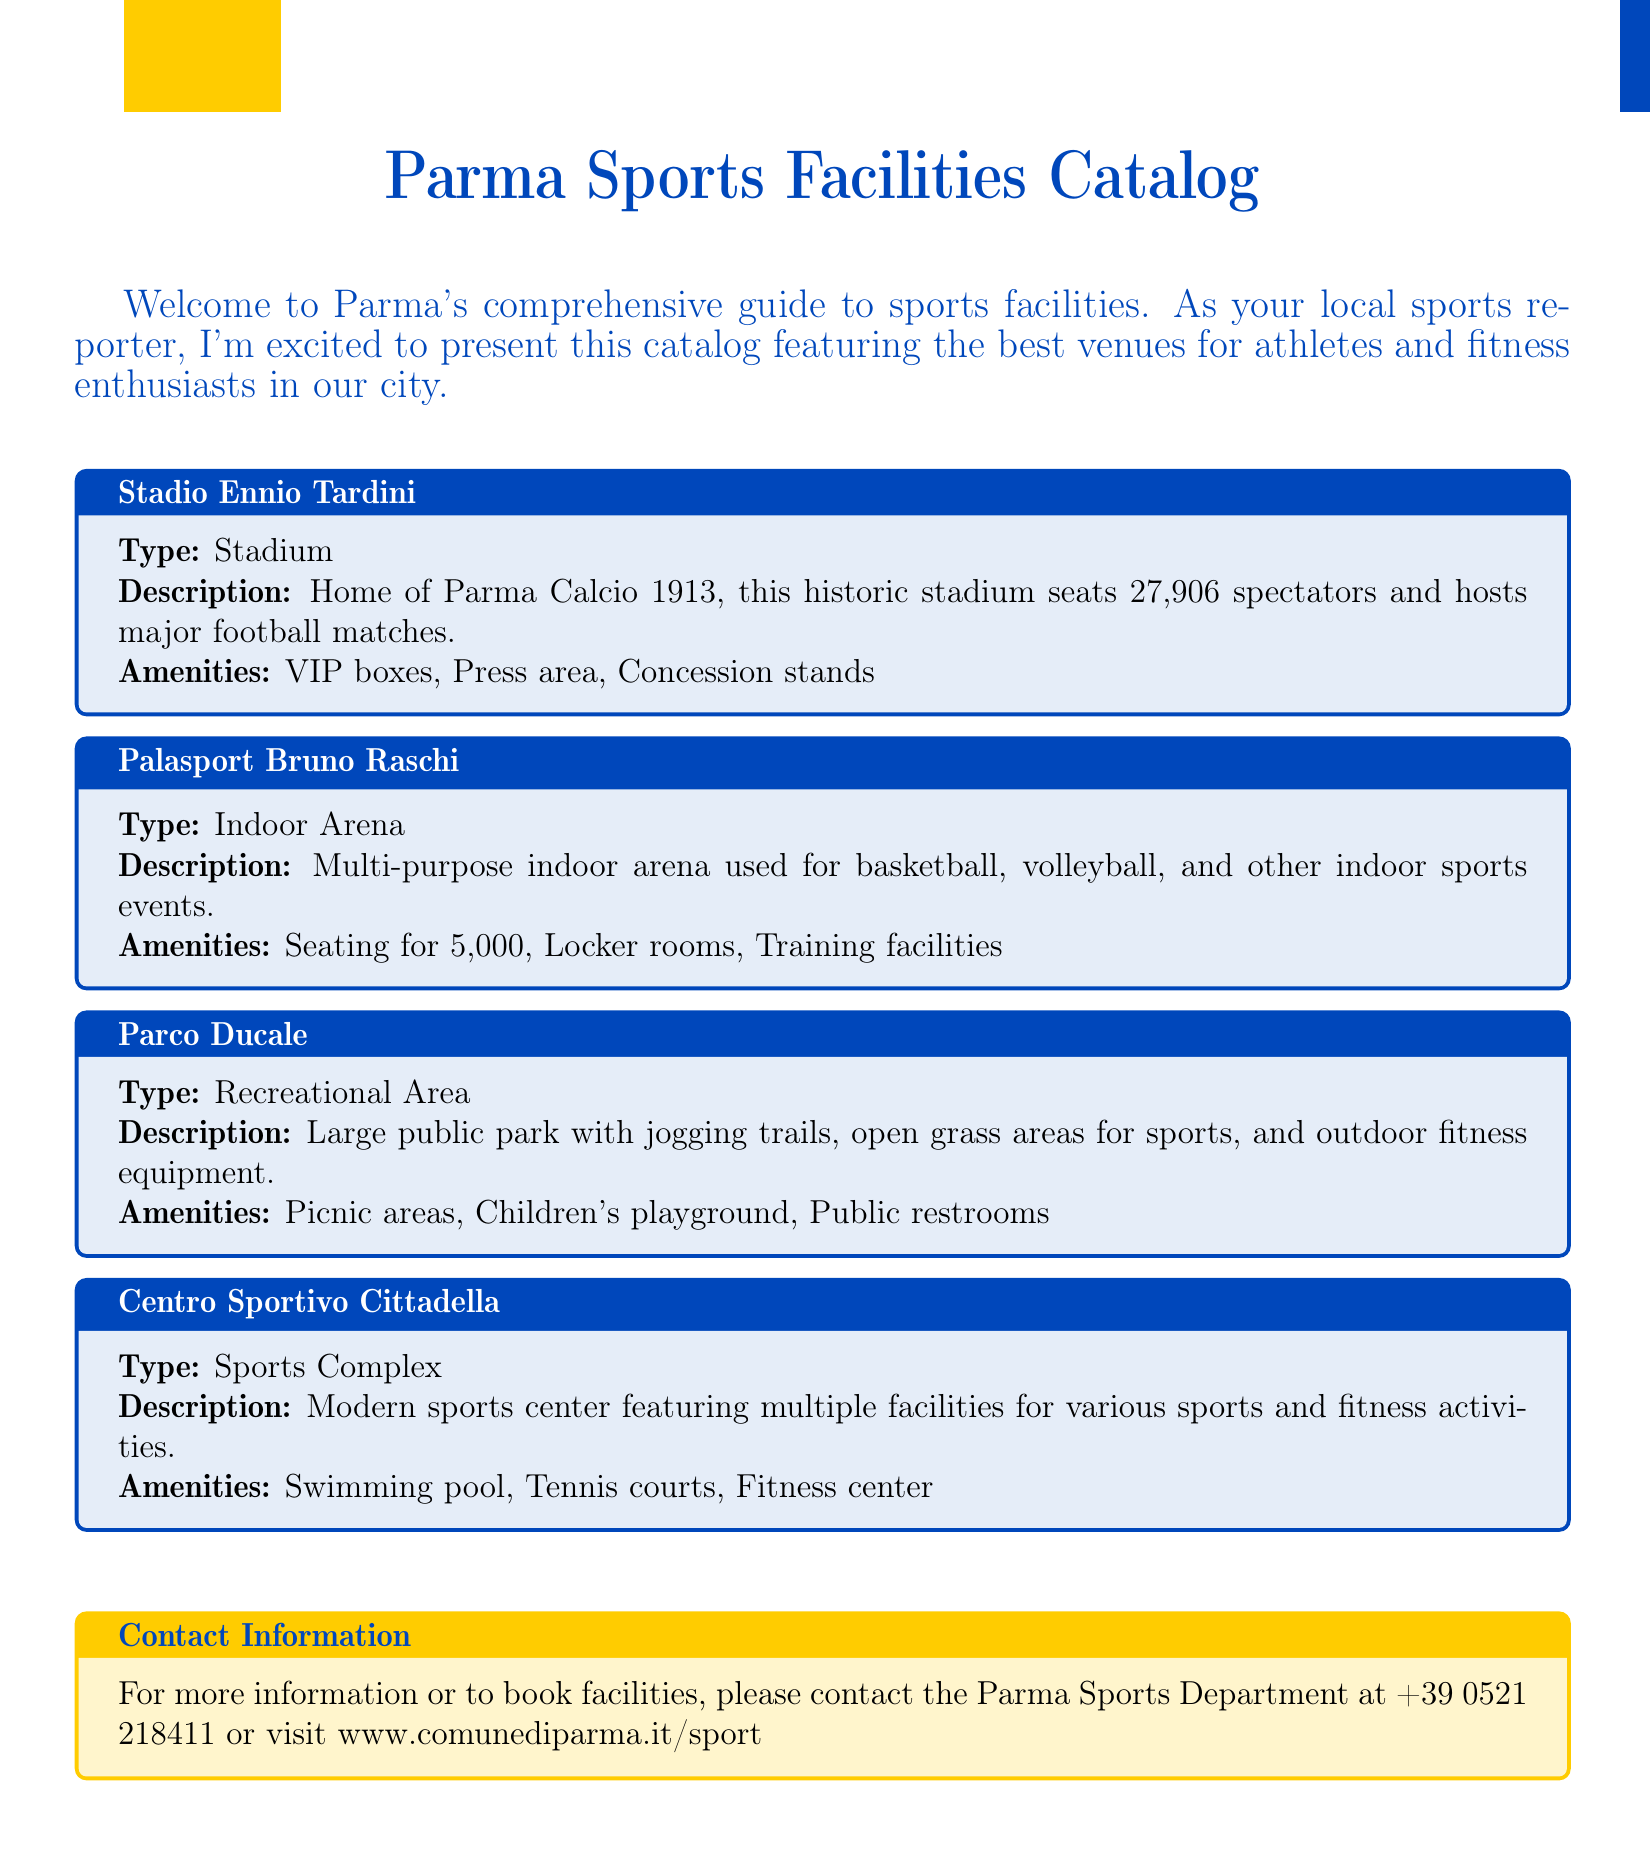What is the seating capacity of Stadio Ennio Tardini? The seating capacity of Stadio Ennio Tardini is mentioned in the document as 27,906.
Answer: 27,906 What type of facility is Palasport Bruno Raschi? The document specifies that Palasport Bruno Raschi is an Indoor Arena.
Answer: Indoor Arena What amenities does Parco Ducale offer? The document lists various amenities provided in Parco Ducale, which include picnic areas, children's playground, and public restrooms.
Answer: Picnic areas, Children's playground, Public restrooms How many spectators can Centro Sportivo Cittadella accommodate? The document doesn't specify a seating capacity for Centro Sportivo Cittadella, but it lists various facilities indicating it's a complex.
Answer: Not specified What is the primary sport hosted at Stadio Ennio Tardini? The document states that Stadio Ennio Tardini is home to Parma Calcio 1913, which indicates that it hosts football matches.
Answer: Football What is the contact number for the Parma Sports Department? The document provides a contact number for the Parma Sports Department which is +39 0521 218411.
Answer: +39 0521 218411 Which facility has locker rooms as an amenity? The document indicates that locker rooms are an amenity of Palasport Bruno Raschi.
Answer: Palasport Bruno Raschi What sports can be played at Centro Sportivo Cittadella? The document lists swimming, tennis, and fitness activities as sports available at Centro Sportivo Cittadella.
Answer: Swimming, Tennis, Fitness activities What are the main activities available at Parco Ducale? The document specifies jogging trails and open grass areas for sports as main activities in Parco Ducale.
Answer: Jogging trails, Open grass areas for sports 